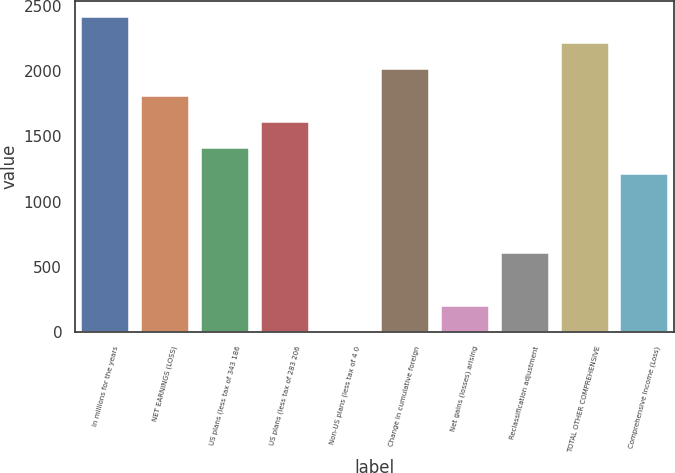Convert chart. <chart><loc_0><loc_0><loc_500><loc_500><bar_chart><fcel>In millions for the years<fcel>NET EARNINGS (LOSS)<fcel>US plans (less tax of 343 186<fcel>US plans (less tax of 283 206<fcel>Non-US plans (less tax of 4 0<fcel>Change in cumulative foreign<fcel>Net gains (losses) arising<fcel>Reclassification adjustment<fcel>TOTAL OTHER COMPREHENSIVE<fcel>Comprehensive Income (Loss)<nl><fcel>2417.6<fcel>1813.7<fcel>1411.1<fcel>1612.4<fcel>2<fcel>2015<fcel>203.3<fcel>605.9<fcel>2216.3<fcel>1209.8<nl></chart> 